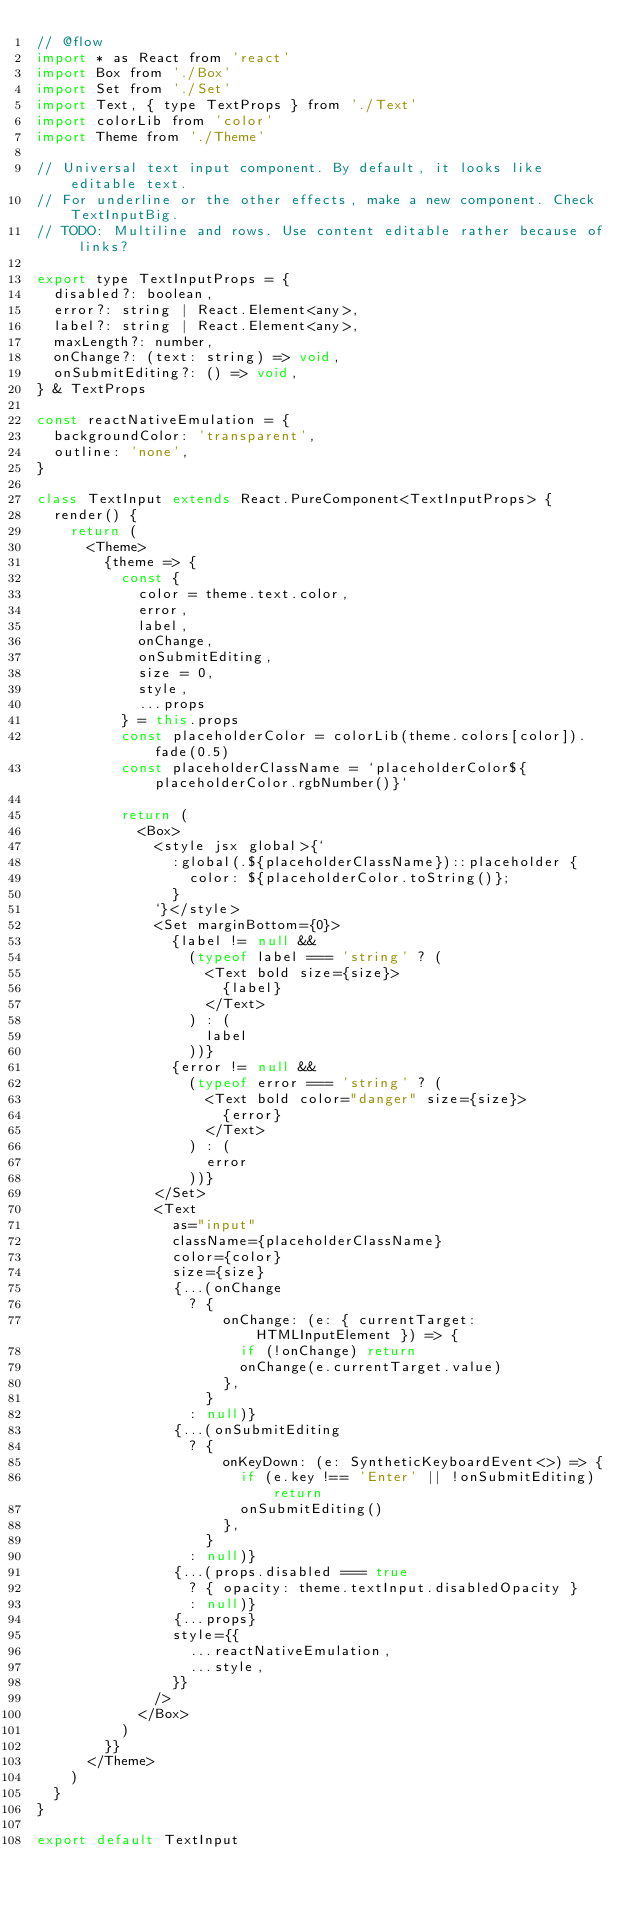<code> <loc_0><loc_0><loc_500><loc_500><_JavaScript_>// @flow
import * as React from 'react'
import Box from './Box'
import Set from './Set'
import Text, { type TextProps } from './Text'
import colorLib from 'color'
import Theme from './Theme'

// Universal text input component. By default, it looks like editable text.
// For underline or the other effects, make a new component. Check TextInputBig.
// TODO: Multiline and rows. Use content editable rather because of links?

export type TextInputProps = {
  disabled?: boolean,
  error?: string | React.Element<any>,
  label?: string | React.Element<any>,
  maxLength?: number,
  onChange?: (text: string) => void,
  onSubmitEditing?: () => void,
} & TextProps

const reactNativeEmulation = {
  backgroundColor: 'transparent',
  outline: 'none',
}

class TextInput extends React.PureComponent<TextInputProps> {
  render() {
    return (
      <Theme>
        {theme => {
          const {
            color = theme.text.color,
            error,
            label,
            onChange,
            onSubmitEditing,
            size = 0,
            style,
            ...props
          } = this.props
          const placeholderColor = colorLib(theme.colors[color]).fade(0.5)
          const placeholderClassName = `placeholderColor${placeholderColor.rgbNumber()}`

          return (
            <Box>
              <style jsx global>{`
                :global(.${placeholderClassName})::placeholder {
                  color: ${placeholderColor.toString()};
                }
              `}</style>
              <Set marginBottom={0}>
                {label != null &&
                  (typeof label === 'string' ? (
                    <Text bold size={size}>
                      {label}
                    </Text>
                  ) : (
                    label
                  ))}
                {error != null &&
                  (typeof error === 'string' ? (
                    <Text bold color="danger" size={size}>
                      {error}
                    </Text>
                  ) : (
                    error
                  ))}
              </Set>
              <Text
                as="input"
                className={placeholderClassName}
                color={color}
                size={size}
                {...(onChange
                  ? {
                      onChange: (e: { currentTarget: HTMLInputElement }) => {
                        if (!onChange) return
                        onChange(e.currentTarget.value)
                      },
                    }
                  : null)}
                {...(onSubmitEditing
                  ? {
                      onKeyDown: (e: SyntheticKeyboardEvent<>) => {
                        if (e.key !== 'Enter' || !onSubmitEditing) return
                        onSubmitEditing()
                      },
                    }
                  : null)}
                {...(props.disabled === true
                  ? { opacity: theme.textInput.disabledOpacity }
                  : null)}
                {...props}
                style={{
                  ...reactNativeEmulation,
                  ...style,
                }}
              />
            </Box>
          )
        }}
      </Theme>
    )
  }
}

export default TextInput
</code> 